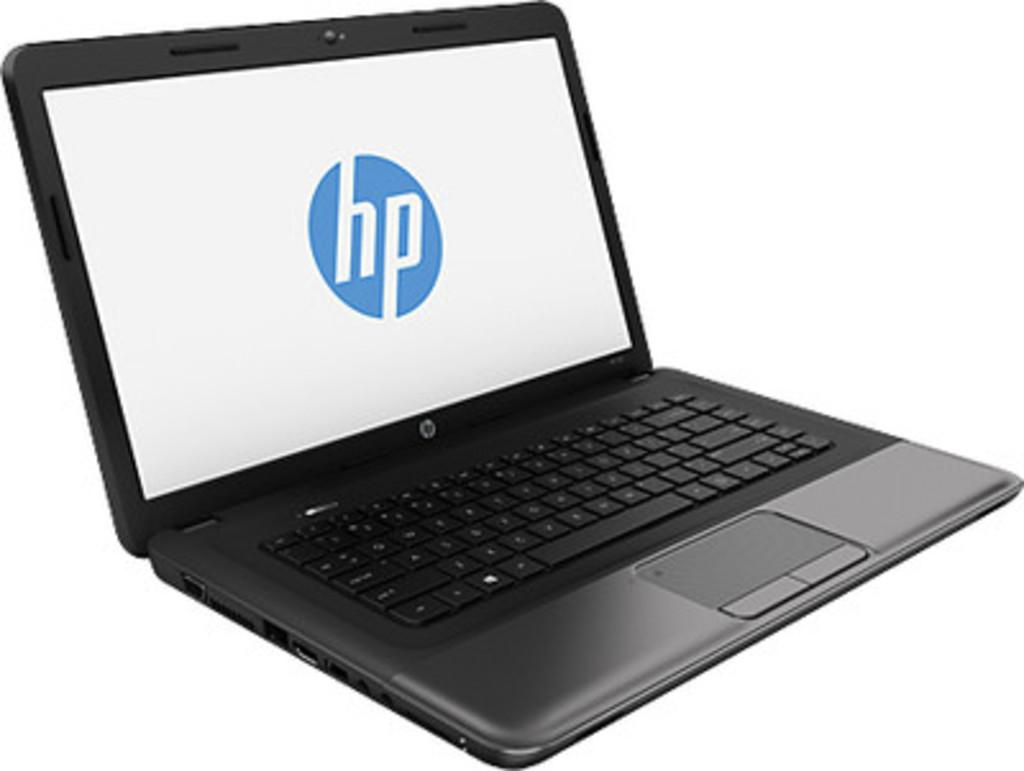<image>
Render a clear and concise summary of the photo. A Hewlett Packard lap top in the color black. 